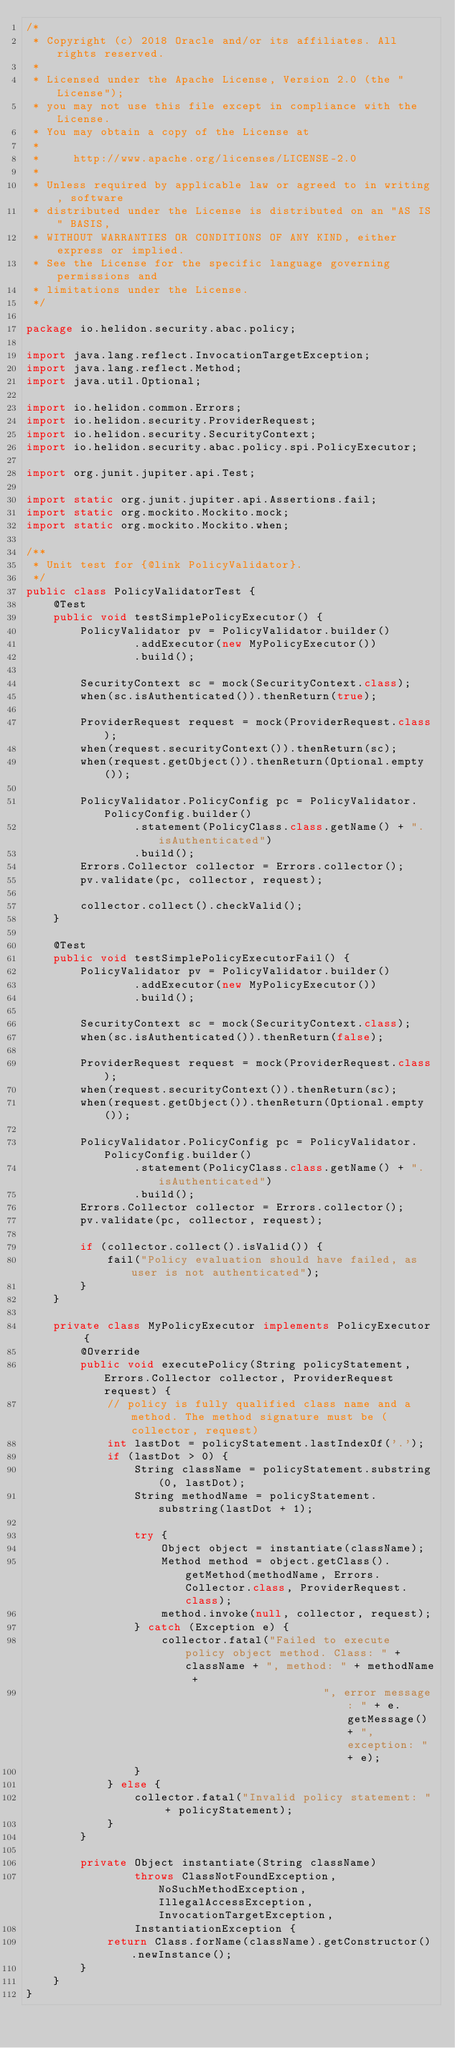Convert code to text. <code><loc_0><loc_0><loc_500><loc_500><_Java_>/*
 * Copyright (c) 2018 Oracle and/or its affiliates. All rights reserved.
 *
 * Licensed under the Apache License, Version 2.0 (the "License");
 * you may not use this file except in compliance with the License.
 * You may obtain a copy of the License at
 *
 *     http://www.apache.org/licenses/LICENSE-2.0
 *
 * Unless required by applicable law or agreed to in writing, software
 * distributed under the License is distributed on an "AS IS" BASIS,
 * WITHOUT WARRANTIES OR CONDITIONS OF ANY KIND, either express or implied.
 * See the License for the specific language governing permissions and
 * limitations under the License.
 */

package io.helidon.security.abac.policy;

import java.lang.reflect.InvocationTargetException;
import java.lang.reflect.Method;
import java.util.Optional;

import io.helidon.common.Errors;
import io.helidon.security.ProviderRequest;
import io.helidon.security.SecurityContext;
import io.helidon.security.abac.policy.spi.PolicyExecutor;

import org.junit.jupiter.api.Test;

import static org.junit.jupiter.api.Assertions.fail;
import static org.mockito.Mockito.mock;
import static org.mockito.Mockito.when;

/**
 * Unit test for {@link PolicyValidator}.
 */
public class PolicyValidatorTest {
    @Test
    public void testSimplePolicyExecutor() {
        PolicyValidator pv = PolicyValidator.builder()
                .addExecutor(new MyPolicyExecutor())
                .build();

        SecurityContext sc = mock(SecurityContext.class);
        when(sc.isAuthenticated()).thenReturn(true);

        ProviderRequest request = mock(ProviderRequest.class);
        when(request.securityContext()).thenReturn(sc);
        when(request.getObject()).thenReturn(Optional.empty());

        PolicyValidator.PolicyConfig pc = PolicyValidator.PolicyConfig.builder()
                .statement(PolicyClass.class.getName() + ".isAuthenticated")
                .build();
        Errors.Collector collector = Errors.collector();
        pv.validate(pc, collector, request);

        collector.collect().checkValid();
    }

    @Test
    public void testSimplePolicyExecutorFail() {
        PolicyValidator pv = PolicyValidator.builder()
                .addExecutor(new MyPolicyExecutor())
                .build();

        SecurityContext sc = mock(SecurityContext.class);
        when(sc.isAuthenticated()).thenReturn(false);

        ProviderRequest request = mock(ProviderRequest.class);
        when(request.securityContext()).thenReturn(sc);
        when(request.getObject()).thenReturn(Optional.empty());

        PolicyValidator.PolicyConfig pc = PolicyValidator.PolicyConfig.builder()
                .statement(PolicyClass.class.getName() + ".isAuthenticated")
                .build();
        Errors.Collector collector = Errors.collector();
        pv.validate(pc, collector, request);

        if (collector.collect().isValid()) {
            fail("Policy evaluation should have failed, as user is not authenticated");
        }
    }

    private class MyPolicyExecutor implements PolicyExecutor {
        @Override
        public void executePolicy(String policyStatement, Errors.Collector collector, ProviderRequest request) {
            // policy is fully qualified class name and a method. The method signature must be (collector, request)
            int lastDot = policyStatement.lastIndexOf('.');
            if (lastDot > 0) {
                String className = policyStatement.substring(0, lastDot);
                String methodName = policyStatement.substring(lastDot + 1);

                try {
                    Object object = instantiate(className);
                    Method method = object.getClass().getMethod(methodName, Errors.Collector.class, ProviderRequest.class);
                    method.invoke(null, collector, request);
                } catch (Exception e) {
                    collector.fatal("Failed to execute policy object method. Class: " + className + ", method: " + methodName +
                                            ", error message: " + e.getMessage() + ", exception: " + e);
                }
            } else {
                collector.fatal("Invalid policy statement: " + policyStatement);
            }
        }

        private Object instantiate(String className)
                throws ClassNotFoundException, NoSuchMethodException, IllegalAccessException, InvocationTargetException,
                InstantiationException {
            return Class.forName(className).getConstructor().newInstance();
        }
    }
}
</code> 